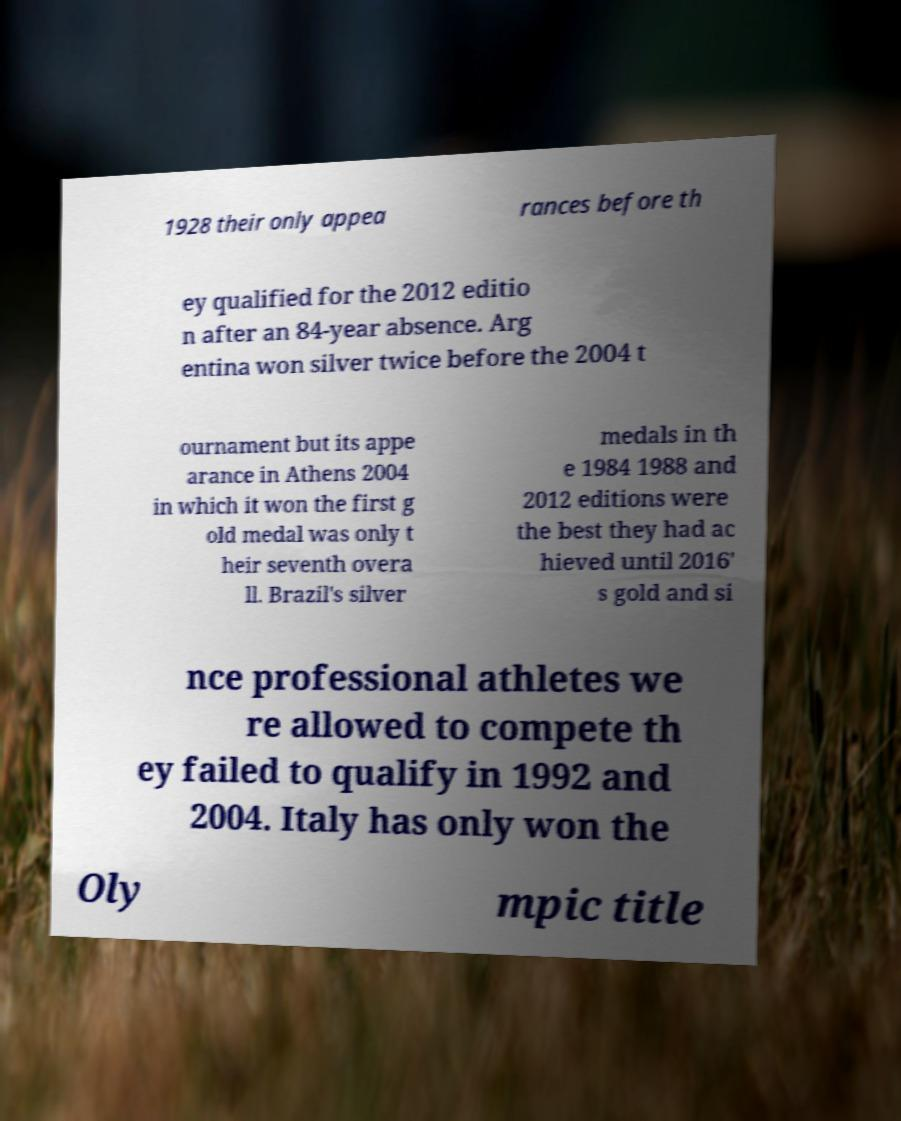I need the written content from this picture converted into text. Can you do that? 1928 their only appea rances before th ey qualified for the 2012 editio n after an 84-year absence. Arg entina won silver twice before the 2004 t ournament but its appe arance in Athens 2004 in which it won the first g old medal was only t heir seventh overa ll. Brazil's silver medals in th e 1984 1988 and 2012 editions were the best they had ac hieved until 2016' s gold and si nce professional athletes we re allowed to compete th ey failed to qualify in 1992 and 2004. Italy has only won the Oly mpic title 